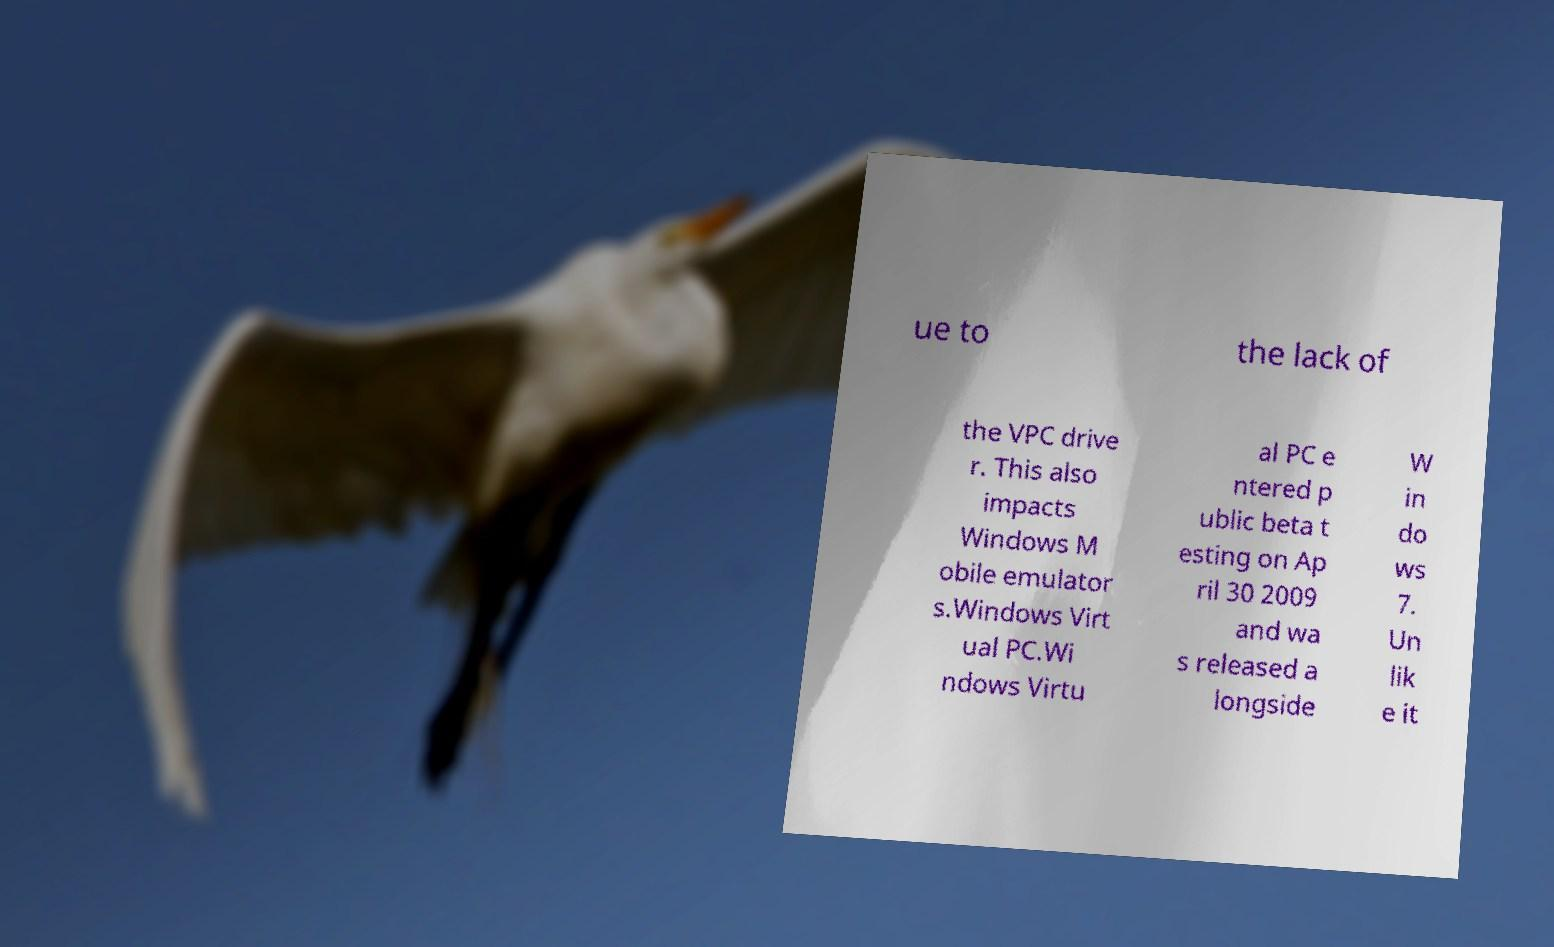Can you accurately transcribe the text from the provided image for me? ue to the lack of the VPC drive r. This also impacts Windows M obile emulator s.Windows Virt ual PC.Wi ndows Virtu al PC e ntered p ublic beta t esting on Ap ril 30 2009 and wa s released a longside W in do ws 7. Un lik e it 